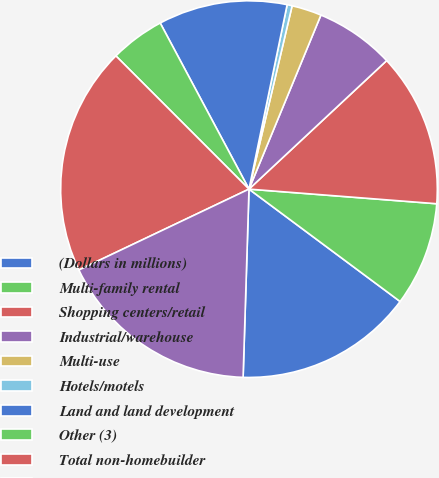<chart> <loc_0><loc_0><loc_500><loc_500><pie_chart><fcel>(Dollars in millions)<fcel>Multi-family rental<fcel>Shopping centers/retail<fcel>Industrial/warehouse<fcel>Multi-use<fcel>Hotels/motels<fcel>Land and land development<fcel>Other (3)<fcel>Total non-homebuilder<fcel>Commercial real estate -<nl><fcel>15.32%<fcel>8.94%<fcel>13.19%<fcel>6.81%<fcel>2.56%<fcel>0.43%<fcel>11.06%<fcel>4.68%<fcel>19.57%<fcel>17.44%<nl></chart> 